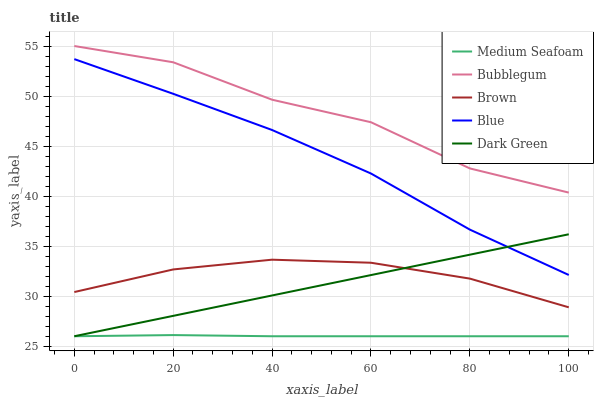Does Medium Seafoam have the minimum area under the curve?
Answer yes or no. Yes. Does Bubblegum have the maximum area under the curve?
Answer yes or no. Yes. Does Brown have the minimum area under the curve?
Answer yes or no. No. Does Brown have the maximum area under the curve?
Answer yes or no. No. Is Dark Green the smoothest?
Answer yes or no. Yes. Is Bubblegum the roughest?
Answer yes or no. Yes. Is Brown the smoothest?
Answer yes or no. No. Is Brown the roughest?
Answer yes or no. No. Does Medium Seafoam have the lowest value?
Answer yes or no. Yes. Does Brown have the lowest value?
Answer yes or no. No. Does Bubblegum have the highest value?
Answer yes or no. Yes. Does Brown have the highest value?
Answer yes or no. No. Is Medium Seafoam less than Brown?
Answer yes or no. Yes. Is Bubblegum greater than Dark Green?
Answer yes or no. Yes. Does Brown intersect Dark Green?
Answer yes or no. Yes. Is Brown less than Dark Green?
Answer yes or no. No. Is Brown greater than Dark Green?
Answer yes or no. No. Does Medium Seafoam intersect Brown?
Answer yes or no. No. 